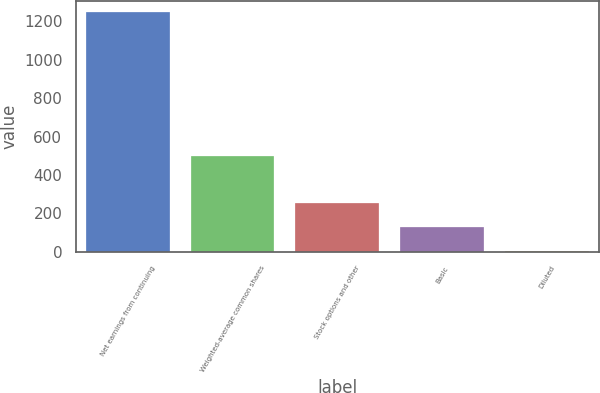Convert chart. <chart><loc_0><loc_0><loc_500><loc_500><bar_chart><fcel>Net earnings from continuing<fcel>Weighted-average common shares<fcel>Stock options and other<fcel>Basic<fcel>Diluted<nl><fcel>1246<fcel>500.53<fcel>252.03<fcel>127.78<fcel>3.53<nl></chart> 